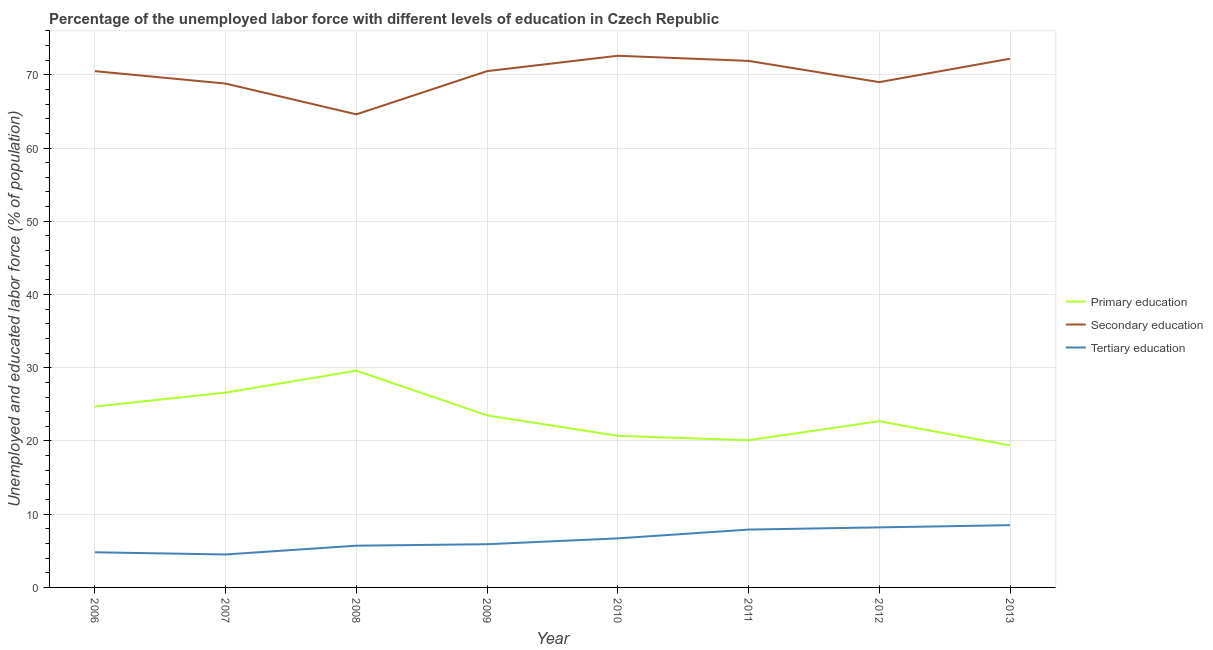How many different coloured lines are there?
Provide a short and direct response. 3. Does the line corresponding to percentage of labor force who received primary education intersect with the line corresponding to percentage of labor force who received tertiary education?
Keep it short and to the point. No. Is the number of lines equal to the number of legend labels?
Provide a short and direct response. Yes. What is the percentage of labor force who received tertiary education in 2011?
Your answer should be very brief. 7.9. Across all years, what is the maximum percentage of labor force who received primary education?
Provide a succinct answer. 29.6. Across all years, what is the minimum percentage of labor force who received secondary education?
Offer a terse response. 64.6. In which year was the percentage of labor force who received tertiary education minimum?
Keep it short and to the point. 2007. What is the total percentage of labor force who received tertiary education in the graph?
Your answer should be compact. 52.2. What is the difference between the percentage of labor force who received tertiary education in 2008 and that in 2011?
Provide a short and direct response. -2.2. What is the difference between the percentage of labor force who received secondary education in 2012 and the percentage of labor force who received tertiary education in 2008?
Provide a short and direct response. 63.3. What is the average percentage of labor force who received primary education per year?
Provide a succinct answer. 23.41. In the year 2009, what is the difference between the percentage of labor force who received secondary education and percentage of labor force who received primary education?
Ensure brevity in your answer.  47. What is the ratio of the percentage of labor force who received tertiary education in 2008 to that in 2010?
Provide a short and direct response. 0.85. Is the percentage of labor force who received tertiary education in 2006 less than that in 2008?
Give a very brief answer. Yes. What is the difference between the highest and the second highest percentage of labor force who received tertiary education?
Offer a very short reply. 0.3. What is the difference between the highest and the lowest percentage of labor force who received primary education?
Make the answer very short. 10.2. Does the percentage of labor force who received tertiary education monotonically increase over the years?
Provide a short and direct response. No. Is the percentage of labor force who received primary education strictly greater than the percentage of labor force who received tertiary education over the years?
Ensure brevity in your answer.  Yes. Is the percentage of labor force who received secondary education strictly less than the percentage of labor force who received primary education over the years?
Give a very brief answer. No. How many lines are there?
Ensure brevity in your answer.  3. How many years are there in the graph?
Your answer should be compact. 8. Are the values on the major ticks of Y-axis written in scientific E-notation?
Your response must be concise. No. Does the graph contain any zero values?
Make the answer very short. No. Where does the legend appear in the graph?
Offer a terse response. Center right. How are the legend labels stacked?
Your answer should be very brief. Vertical. What is the title of the graph?
Offer a very short reply. Percentage of the unemployed labor force with different levels of education in Czech Republic. Does "Labor Tax" appear as one of the legend labels in the graph?
Offer a terse response. No. What is the label or title of the X-axis?
Give a very brief answer. Year. What is the label or title of the Y-axis?
Offer a very short reply. Unemployed and educated labor force (% of population). What is the Unemployed and educated labor force (% of population) in Primary education in 2006?
Your response must be concise. 24.7. What is the Unemployed and educated labor force (% of population) in Secondary education in 2006?
Provide a succinct answer. 70.5. What is the Unemployed and educated labor force (% of population) of Tertiary education in 2006?
Your answer should be very brief. 4.8. What is the Unemployed and educated labor force (% of population) in Primary education in 2007?
Give a very brief answer. 26.6. What is the Unemployed and educated labor force (% of population) of Secondary education in 2007?
Keep it short and to the point. 68.8. What is the Unemployed and educated labor force (% of population) in Primary education in 2008?
Provide a succinct answer. 29.6. What is the Unemployed and educated labor force (% of population) of Secondary education in 2008?
Ensure brevity in your answer.  64.6. What is the Unemployed and educated labor force (% of population) in Tertiary education in 2008?
Make the answer very short. 5.7. What is the Unemployed and educated labor force (% of population) of Secondary education in 2009?
Ensure brevity in your answer.  70.5. What is the Unemployed and educated labor force (% of population) in Tertiary education in 2009?
Your answer should be compact. 5.9. What is the Unemployed and educated labor force (% of population) of Primary education in 2010?
Give a very brief answer. 20.7. What is the Unemployed and educated labor force (% of population) in Secondary education in 2010?
Give a very brief answer. 72.6. What is the Unemployed and educated labor force (% of population) of Tertiary education in 2010?
Give a very brief answer. 6.7. What is the Unemployed and educated labor force (% of population) in Primary education in 2011?
Keep it short and to the point. 20.1. What is the Unemployed and educated labor force (% of population) of Secondary education in 2011?
Offer a terse response. 71.9. What is the Unemployed and educated labor force (% of population) of Tertiary education in 2011?
Provide a succinct answer. 7.9. What is the Unemployed and educated labor force (% of population) of Primary education in 2012?
Provide a short and direct response. 22.7. What is the Unemployed and educated labor force (% of population) in Secondary education in 2012?
Offer a terse response. 69. What is the Unemployed and educated labor force (% of population) of Tertiary education in 2012?
Offer a very short reply. 8.2. What is the Unemployed and educated labor force (% of population) of Primary education in 2013?
Keep it short and to the point. 19.4. What is the Unemployed and educated labor force (% of population) of Secondary education in 2013?
Your answer should be compact. 72.2. What is the Unemployed and educated labor force (% of population) of Tertiary education in 2013?
Your response must be concise. 8.5. Across all years, what is the maximum Unemployed and educated labor force (% of population) in Primary education?
Ensure brevity in your answer.  29.6. Across all years, what is the maximum Unemployed and educated labor force (% of population) of Secondary education?
Give a very brief answer. 72.6. Across all years, what is the minimum Unemployed and educated labor force (% of population) in Primary education?
Offer a very short reply. 19.4. Across all years, what is the minimum Unemployed and educated labor force (% of population) of Secondary education?
Provide a short and direct response. 64.6. Across all years, what is the minimum Unemployed and educated labor force (% of population) of Tertiary education?
Offer a very short reply. 4.5. What is the total Unemployed and educated labor force (% of population) in Primary education in the graph?
Ensure brevity in your answer.  187.3. What is the total Unemployed and educated labor force (% of population) of Secondary education in the graph?
Ensure brevity in your answer.  560.1. What is the total Unemployed and educated labor force (% of population) in Tertiary education in the graph?
Provide a short and direct response. 52.2. What is the difference between the Unemployed and educated labor force (% of population) of Primary education in 2006 and that in 2007?
Provide a succinct answer. -1.9. What is the difference between the Unemployed and educated labor force (% of population) in Primary education in 2006 and that in 2008?
Your response must be concise. -4.9. What is the difference between the Unemployed and educated labor force (% of population) of Secondary education in 2006 and that in 2008?
Your answer should be very brief. 5.9. What is the difference between the Unemployed and educated labor force (% of population) in Tertiary education in 2006 and that in 2008?
Offer a very short reply. -0.9. What is the difference between the Unemployed and educated labor force (% of population) in Secondary education in 2006 and that in 2009?
Provide a short and direct response. 0. What is the difference between the Unemployed and educated labor force (% of population) in Tertiary education in 2006 and that in 2009?
Your response must be concise. -1.1. What is the difference between the Unemployed and educated labor force (% of population) in Primary education in 2006 and that in 2010?
Your response must be concise. 4. What is the difference between the Unemployed and educated labor force (% of population) in Secondary education in 2006 and that in 2010?
Your answer should be compact. -2.1. What is the difference between the Unemployed and educated labor force (% of population) in Tertiary education in 2006 and that in 2010?
Offer a terse response. -1.9. What is the difference between the Unemployed and educated labor force (% of population) of Secondary education in 2006 and that in 2012?
Give a very brief answer. 1.5. What is the difference between the Unemployed and educated labor force (% of population) of Tertiary education in 2006 and that in 2012?
Your answer should be compact. -3.4. What is the difference between the Unemployed and educated labor force (% of population) in Primary education in 2006 and that in 2013?
Give a very brief answer. 5.3. What is the difference between the Unemployed and educated labor force (% of population) of Secondary education in 2006 and that in 2013?
Keep it short and to the point. -1.7. What is the difference between the Unemployed and educated labor force (% of population) of Primary education in 2007 and that in 2008?
Your response must be concise. -3. What is the difference between the Unemployed and educated labor force (% of population) in Secondary education in 2007 and that in 2008?
Offer a terse response. 4.2. What is the difference between the Unemployed and educated labor force (% of population) of Primary education in 2007 and that in 2009?
Provide a succinct answer. 3.1. What is the difference between the Unemployed and educated labor force (% of population) in Secondary education in 2007 and that in 2009?
Provide a succinct answer. -1.7. What is the difference between the Unemployed and educated labor force (% of population) of Tertiary education in 2007 and that in 2009?
Give a very brief answer. -1.4. What is the difference between the Unemployed and educated labor force (% of population) in Tertiary education in 2007 and that in 2010?
Offer a very short reply. -2.2. What is the difference between the Unemployed and educated labor force (% of population) of Secondary education in 2007 and that in 2011?
Ensure brevity in your answer.  -3.1. What is the difference between the Unemployed and educated labor force (% of population) of Primary education in 2007 and that in 2013?
Give a very brief answer. 7.2. What is the difference between the Unemployed and educated labor force (% of population) of Secondary education in 2007 and that in 2013?
Make the answer very short. -3.4. What is the difference between the Unemployed and educated labor force (% of population) in Tertiary education in 2007 and that in 2013?
Give a very brief answer. -4. What is the difference between the Unemployed and educated labor force (% of population) of Tertiary education in 2008 and that in 2009?
Ensure brevity in your answer.  -0.2. What is the difference between the Unemployed and educated labor force (% of population) of Primary education in 2008 and that in 2010?
Keep it short and to the point. 8.9. What is the difference between the Unemployed and educated labor force (% of population) of Primary education in 2008 and that in 2012?
Your answer should be compact. 6.9. What is the difference between the Unemployed and educated labor force (% of population) in Secondary education in 2008 and that in 2012?
Provide a short and direct response. -4.4. What is the difference between the Unemployed and educated labor force (% of population) in Tertiary education in 2008 and that in 2012?
Provide a short and direct response. -2.5. What is the difference between the Unemployed and educated labor force (% of population) of Secondary education in 2008 and that in 2013?
Make the answer very short. -7.6. What is the difference between the Unemployed and educated labor force (% of population) in Primary education in 2009 and that in 2010?
Your answer should be compact. 2.8. What is the difference between the Unemployed and educated labor force (% of population) in Primary education in 2009 and that in 2011?
Keep it short and to the point. 3.4. What is the difference between the Unemployed and educated labor force (% of population) in Secondary education in 2009 and that in 2011?
Offer a very short reply. -1.4. What is the difference between the Unemployed and educated labor force (% of population) of Tertiary education in 2009 and that in 2011?
Provide a succinct answer. -2. What is the difference between the Unemployed and educated labor force (% of population) of Primary education in 2009 and that in 2012?
Your answer should be compact. 0.8. What is the difference between the Unemployed and educated labor force (% of population) of Secondary education in 2009 and that in 2012?
Your answer should be compact. 1.5. What is the difference between the Unemployed and educated labor force (% of population) of Primary education in 2010 and that in 2011?
Your response must be concise. 0.6. What is the difference between the Unemployed and educated labor force (% of population) of Secondary education in 2010 and that in 2011?
Your answer should be compact. 0.7. What is the difference between the Unemployed and educated labor force (% of population) in Primary education in 2010 and that in 2012?
Keep it short and to the point. -2. What is the difference between the Unemployed and educated labor force (% of population) of Secondary education in 2010 and that in 2012?
Keep it short and to the point. 3.6. What is the difference between the Unemployed and educated labor force (% of population) of Tertiary education in 2010 and that in 2012?
Ensure brevity in your answer.  -1.5. What is the difference between the Unemployed and educated labor force (% of population) in Primary education in 2010 and that in 2013?
Keep it short and to the point. 1.3. What is the difference between the Unemployed and educated labor force (% of population) in Secondary education in 2011 and that in 2012?
Ensure brevity in your answer.  2.9. What is the difference between the Unemployed and educated labor force (% of population) in Primary education in 2011 and that in 2013?
Ensure brevity in your answer.  0.7. What is the difference between the Unemployed and educated labor force (% of population) in Tertiary education in 2011 and that in 2013?
Your answer should be compact. -0.6. What is the difference between the Unemployed and educated labor force (% of population) of Primary education in 2012 and that in 2013?
Give a very brief answer. 3.3. What is the difference between the Unemployed and educated labor force (% of population) in Secondary education in 2012 and that in 2013?
Keep it short and to the point. -3.2. What is the difference between the Unemployed and educated labor force (% of population) in Tertiary education in 2012 and that in 2013?
Offer a very short reply. -0.3. What is the difference between the Unemployed and educated labor force (% of population) in Primary education in 2006 and the Unemployed and educated labor force (% of population) in Secondary education in 2007?
Ensure brevity in your answer.  -44.1. What is the difference between the Unemployed and educated labor force (% of population) in Primary education in 2006 and the Unemployed and educated labor force (% of population) in Tertiary education in 2007?
Your answer should be compact. 20.2. What is the difference between the Unemployed and educated labor force (% of population) of Primary education in 2006 and the Unemployed and educated labor force (% of population) of Secondary education in 2008?
Your answer should be very brief. -39.9. What is the difference between the Unemployed and educated labor force (% of population) in Primary education in 2006 and the Unemployed and educated labor force (% of population) in Tertiary education in 2008?
Offer a very short reply. 19. What is the difference between the Unemployed and educated labor force (% of population) of Secondary education in 2006 and the Unemployed and educated labor force (% of population) of Tertiary education in 2008?
Your answer should be very brief. 64.8. What is the difference between the Unemployed and educated labor force (% of population) in Primary education in 2006 and the Unemployed and educated labor force (% of population) in Secondary education in 2009?
Make the answer very short. -45.8. What is the difference between the Unemployed and educated labor force (% of population) in Secondary education in 2006 and the Unemployed and educated labor force (% of population) in Tertiary education in 2009?
Your answer should be very brief. 64.6. What is the difference between the Unemployed and educated labor force (% of population) in Primary education in 2006 and the Unemployed and educated labor force (% of population) in Secondary education in 2010?
Ensure brevity in your answer.  -47.9. What is the difference between the Unemployed and educated labor force (% of population) of Primary education in 2006 and the Unemployed and educated labor force (% of population) of Tertiary education in 2010?
Give a very brief answer. 18. What is the difference between the Unemployed and educated labor force (% of population) in Secondary education in 2006 and the Unemployed and educated labor force (% of population) in Tertiary education in 2010?
Offer a very short reply. 63.8. What is the difference between the Unemployed and educated labor force (% of population) in Primary education in 2006 and the Unemployed and educated labor force (% of population) in Secondary education in 2011?
Your response must be concise. -47.2. What is the difference between the Unemployed and educated labor force (% of population) of Primary education in 2006 and the Unemployed and educated labor force (% of population) of Tertiary education in 2011?
Ensure brevity in your answer.  16.8. What is the difference between the Unemployed and educated labor force (% of population) in Secondary education in 2006 and the Unemployed and educated labor force (% of population) in Tertiary education in 2011?
Give a very brief answer. 62.6. What is the difference between the Unemployed and educated labor force (% of population) of Primary education in 2006 and the Unemployed and educated labor force (% of population) of Secondary education in 2012?
Offer a very short reply. -44.3. What is the difference between the Unemployed and educated labor force (% of population) of Primary education in 2006 and the Unemployed and educated labor force (% of population) of Tertiary education in 2012?
Provide a succinct answer. 16.5. What is the difference between the Unemployed and educated labor force (% of population) of Secondary education in 2006 and the Unemployed and educated labor force (% of population) of Tertiary education in 2012?
Offer a terse response. 62.3. What is the difference between the Unemployed and educated labor force (% of population) in Primary education in 2006 and the Unemployed and educated labor force (% of population) in Secondary education in 2013?
Make the answer very short. -47.5. What is the difference between the Unemployed and educated labor force (% of population) in Primary education in 2006 and the Unemployed and educated labor force (% of population) in Tertiary education in 2013?
Offer a very short reply. 16.2. What is the difference between the Unemployed and educated labor force (% of population) in Primary education in 2007 and the Unemployed and educated labor force (% of population) in Secondary education in 2008?
Your response must be concise. -38. What is the difference between the Unemployed and educated labor force (% of population) in Primary education in 2007 and the Unemployed and educated labor force (% of population) in Tertiary education in 2008?
Provide a short and direct response. 20.9. What is the difference between the Unemployed and educated labor force (% of population) of Secondary education in 2007 and the Unemployed and educated labor force (% of population) of Tertiary education in 2008?
Offer a terse response. 63.1. What is the difference between the Unemployed and educated labor force (% of population) in Primary education in 2007 and the Unemployed and educated labor force (% of population) in Secondary education in 2009?
Offer a terse response. -43.9. What is the difference between the Unemployed and educated labor force (% of population) of Primary education in 2007 and the Unemployed and educated labor force (% of population) of Tertiary education in 2009?
Your response must be concise. 20.7. What is the difference between the Unemployed and educated labor force (% of population) of Secondary education in 2007 and the Unemployed and educated labor force (% of population) of Tertiary education in 2009?
Offer a terse response. 62.9. What is the difference between the Unemployed and educated labor force (% of population) of Primary education in 2007 and the Unemployed and educated labor force (% of population) of Secondary education in 2010?
Offer a very short reply. -46. What is the difference between the Unemployed and educated labor force (% of population) of Primary education in 2007 and the Unemployed and educated labor force (% of population) of Tertiary education in 2010?
Provide a succinct answer. 19.9. What is the difference between the Unemployed and educated labor force (% of population) in Secondary education in 2007 and the Unemployed and educated labor force (% of population) in Tertiary education in 2010?
Make the answer very short. 62.1. What is the difference between the Unemployed and educated labor force (% of population) of Primary education in 2007 and the Unemployed and educated labor force (% of population) of Secondary education in 2011?
Provide a succinct answer. -45.3. What is the difference between the Unemployed and educated labor force (% of population) of Primary education in 2007 and the Unemployed and educated labor force (% of population) of Tertiary education in 2011?
Your answer should be very brief. 18.7. What is the difference between the Unemployed and educated labor force (% of population) of Secondary education in 2007 and the Unemployed and educated labor force (% of population) of Tertiary education in 2011?
Offer a terse response. 60.9. What is the difference between the Unemployed and educated labor force (% of population) in Primary education in 2007 and the Unemployed and educated labor force (% of population) in Secondary education in 2012?
Offer a terse response. -42.4. What is the difference between the Unemployed and educated labor force (% of population) of Primary education in 2007 and the Unemployed and educated labor force (% of population) of Tertiary education in 2012?
Offer a terse response. 18.4. What is the difference between the Unemployed and educated labor force (% of population) of Secondary education in 2007 and the Unemployed and educated labor force (% of population) of Tertiary education in 2012?
Your answer should be compact. 60.6. What is the difference between the Unemployed and educated labor force (% of population) in Primary education in 2007 and the Unemployed and educated labor force (% of population) in Secondary education in 2013?
Ensure brevity in your answer.  -45.6. What is the difference between the Unemployed and educated labor force (% of population) of Secondary education in 2007 and the Unemployed and educated labor force (% of population) of Tertiary education in 2013?
Offer a terse response. 60.3. What is the difference between the Unemployed and educated labor force (% of population) of Primary education in 2008 and the Unemployed and educated labor force (% of population) of Secondary education in 2009?
Provide a succinct answer. -40.9. What is the difference between the Unemployed and educated labor force (% of population) of Primary education in 2008 and the Unemployed and educated labor force (% of population) of Tertiary education in 2009?
Offer a very short reply. 23.7. What is the difference between the Unemployed and educated labor force (% of population) of Secondary education in 2008 and the Unemployed and educated labor force (% of population) of Tertiary education in 2009?
Your answer should be very brief. 58.7. What is the difference between the Unemployed and educated labor force (% of population) of Primary education in 2008 and the Unemployed and educated labor force (% of population) of Secondary education in 2010?
Offer a very short reply. -43. What is the difference between the Unemployed and educated labor force (% of population) in Primary education in 2008 and the Unemployed and educated labor force (% of population) in Tertiary education in 2010?
Offer a terse response. 22.9. What is the difference between the Unemployed and educated labor force (% of population) in Secondary education in 2008 and the Unemployed and educated labor force (% of population) in Tertiary education in 2010?
Give a very brief answer. 57.9. What is the difference between the Unemployed and educated labor force (% of population) in Primary education in 2008 and the Unemployed and educated labor force (% of population) in Secondary education in 2011?
Your answer should be very brief. -42.3. What is the difference between the Unemployed and educated labor force (% of population) of Primary education in 2008 and the Unemployed and educated labor force (% of population) of Tertiary education in 2011?
Keep it short and to the point. 21.7. What is the difference between the Unemployed and educated labor force (% of population) in Secondary education in 2008 and the Unemployed and educated labor force (% of population) in Tertiary education in 2011?
Keep it short and to the point. 56.7. What is the difference between the Unemployed and educated labor force (% of population) in Primary education in 2008 and the Unemployed and educated labor force (% of population) in Secondary education in 2012?
Keep it short and to the point. -39.4. What is the difference between the Unemployed and educated labor force (% of population) in Primary education in 2008 and the Unemployed and educated labor force (% of population) in Tertiary education in 2012?
Your answer should be very brief. 21.4. What is the difference between the Unemployed and educated labor force (% of population) of Secondary education in 2008 and the Unemployed and educated labor force (% of population) of Tertiary education in 2012?
Give a very brief answer. 56.4. What is the difference between the Unemployed and educated labor force (% of population) of Primary education in 2008 and the Unemployed and educated labor force (% of population) of Secondary education in 2013?
Make the answer very short. -42.6. What is the difference between the Unemployed and educated labor force (% of population) of Primary education in 2008 and the Unemployed and educated labor force (% of population) of Tertiary education in 2013?
Keep it short and to the point. 21.1. What is the difference between the Unemployed and educated labor force (% of population) in Secondary education in 2008 and the Unemployed and educated labor force (% of population) in Tertiary education in 2013?
Your answer should be compact. 56.1. What is the difference between the Unemployed and educated labor force (% of population) in Primary education in 2009 and the Unemployed and educated labor force (% of population) in Secondary education in 2010?
Your response must be concise. -49.1. What is the difference between the Unemployed and educated labor force (% of population) in Primary education in 2009 and the Unemployed and educated labor force (% of population) in Tertiary education in 2010?
Your response must be concise. 16.8. What is the difference between the Unemployed and educated labor force (% of population) of Secondary education in 2009 and the Unemployed and educated labor force (% of population) of Tertiary education in 2010?
Ensure brevity in your answer.  63.8. What is the difference between the Unemployed and educated labor force (% of population) of Primary education in 2009 and the Unemployed and educated labor force (% of population) of Secondary education in 2011?
Give a very brief answer. -48.4. What is the difference between the Unemployed and educated labor force (% of population) of Primary education in 2009 and the Unemployed and educated labor force (% of population) of Tertiary education in 2011?
Ensure brevity in your answer.  15.6. What is the difference between the Unemployed and educated labor force (% of population) of Secondary education in 2009 and the Unemployed and educated labor force (% of population) of Tertiary education in 2011?
Provide a short and direct response. 62.6. What is the difference between the Unemployed and educated labor force (% of population) of Primary education in 2009 and the Unemployed and educated labor force (% of population) of Secondary education in 2012?
Offer a very short reply. -45.5. What is the difference between the Unemployed and educated labor force (% of population) of Primary education in 2009 and the Unemployed and educated labor force (% of population) of Tertiary education in 2012?
Make the answer very short. 15.3. What is the difference between the Unemployed and educated labor force (% of population) in Secondary education in 2009 and the Unemployed and educated labor force (% of population) in Tertiary education in 2012?
Your answer should be very brief. 62.3. What is the difference between the Unemployed and educated labor force (% of population) in Primary education in 2009 and the Unemployed and educated labor force (% of population) in Secondary education in 2013?
Your response must be concise. -48.7. What is the difference between the Unemployed and educated labor force (% of population) of Primary education in 2009 and the Unemployed and educated labor force (% of population) of Tertiary education in 2013?
Offer a very short reply. 15. What is the difference between the Unemployed and educated labor force (% of population) in Secondary education in 2009 and the Unemployed and educated labor force (% of population) in Tertiary education in 2013?
Your answer should be compact. 62. What is the difference between the Unemployed and educated labor force (% of population) of Primary education in 2010 and the Unemployed and educated labor force (% of population) of Secondary education in 2011?
Keep it short and to the point. -51.2. What is the difference between the Unemployed and educated labor force (% of population) of Secondary education in 2010 and the Unemployed and educated labor force (% of population) of Tertiary education in 2011?
Keep it short and to the point. 64.7. What is the difference between the Unemployed and educated labor force (% of population) in Primary education in 2010 and the Unemployed and educated labor force (% of population) in Secondary education in 2012?
Provide a short and direct response. -48.3. What is the difference between the Unemployed and educated labor force (% of population) of Secondary education in 2010 and the Unemployed and educated labor force (% of population) of Tertiary education in 2012?
Offer a very short reply. 64.4. What is the difference between the Unemployed and educated labor force (% of population) of Primary education in 2010 and the Unemployed and educated labor force (% of population) of Secondary education in 2013?
Offer a very short reply. -51.5. What is the difference between the Unemployed and educated labor force (% of population) of Primary education in 2010 and the Unemployed and educated labor force (% of population) of Tertiary education in 2013?
Give a very brief answer. 12.2. What is the difference between the Unemployed and educated labor force (% of population) of Secondary education in 2010 and the Unemployed and educated labor force (% of population) of Tertiary education in 2013?
Provide a succinct answer. 64.1. What is the difference between the Unemployed and educated labor force (% of population) of Primary education in 2011 and the Unemployed and educated labor force (% of population) of Secondary education in 2012?
Your answer should be very brief. -48.9. What is the difference between the Unemployed and educated labor force (% of population) in Secondary education in 2011 and the Unemployed and educated labor force (% of population) in Tertiary education in 2012?
Give a very brief answer. 63.7. What is the difference between the Unemployed and educated labor force (% of population) of Primary education in 2011 and the Unemployed and educated labor force (% of population) of Secondary education in 2013?
Ensure brevity in your answer.  -52.1. What is the difference between the Unemployed and educated labor force (% of population) of Primary education in 2011 and the Unemployed and educated labor force (% of population) of Tertiary education in 2013?
Give a very brief answer. 11.6. What is the difference between the Unemployed and educated labor force (% of population) of Secondary education in 2011 and the Unemployed and educated labor force (% of population) of Tertiary education in 2013?
Provide a short and direct response. 63.4. What is the difference between the Unemployed and educated labor force (% of population) in Primary education in 2012 and the Unemployed and educated labor force (% of population) in Secondary education in 2013?
Your response must be concise. -49.5. What is the difference between the Unemployed and educated labor force (% of population) of Secondary education in 2012 and the Unemployed and educated labor force (% of population) of Tertiary education in 2013?
Your answer should be compact. 60.5. What is the average Unemployed and educated labor force (% of population) in Primary education per year?
Provide a succinct answer. 23.41. What is the average Unemployed and educated labor force (% of population) of Secondary education per year?
Ensure brevity in your answer.  70.01. What is the average Unemployed and educated labor force (% of population) in Tertiary education per year?
Ensure brevity in your answer.  6.53. In the year 2006, what is the difference between the Unemployed and educated labor force (% of population) in Primary education and Unemployed and educated labor force (% of population) in Secondary education?
Your answer should be compact. -45.8. In the year 2006, what is the difference between the Unemployed and educated labor force (% of population) of Primary education and Unemployed and educated labor force (% of population) of Tertiary education?
Provide a short and direct response. 19.9. In the year 2006, what is the difference between the Unemployed and educated labor force (% of population) in Secondary education and Unemployed and educated labor force (% of population) in Tertiary education?
Offer a very short reply. 65.7. In the year 2007, what is the difference between the Unemployed and educated labor force (% of population) in Primary education and Unemployed and educated labor force (% of population) in Secondary education?
Offer a very short reply. -42.2. In the year 2007, what is the difference between the Unemployed and educated labor force (% of population) of Primary education and Unemployed and educated labor force (% of population) of Tertiary education?
Make the answer very short. 22.1. In the year 2007, what is the difference between the Unemployed and educated labor force (% of population) in Secondary education and Unemployed and educated labor force (% of population) in Tertiary education?
Make the answer very short. 64.3. In the year 2008, what is the difference between the Unemployed and educated labor force (% of population) of Primary education and Unemployed and educated labor force (% of population) of Secondary education?
Your response must be concise. -35. In the year 2008, what is the difference between the Unemployed and educated labor force (% of population) in Primary education and Unemployed and educated labor force (% of population) in Tertiary education?
Provide a short and direct response. 23.9. In the year 2008, what is the difference between the Unemployed and educated labor force (% of population) of Secondary education and Unemployed and educated labor force (% of population) of Tertiary education?
Your answer should be compact. 58.9. In the year 2009, what is the difference between the Unemployed and educated labor force (% of population) in Primary education and Unemployed and educated labor force (% of population) in Secondary education?
Give a very brief answer. -47. In the year 2009, what is the difference between the Unemployed and educated labor force (% of population) of Secondary education and Unemployed and educated labor force (% of population) of Tertiary education?
Keep it short and to the point. 64.6. In the year 2010, what is the difference between the Unemployed and educated labor force (% of population) in Primary education and Unemployed and educated labor force (% of population) in Secondary education?
Make the answer very short. -51.9. In the year 2010, what is the difference between the Unemployed and educated labor force (% of population) in Primary education and Unemployed and educated labor force (% of population) in Tertiary education?
Your response must be concise. 14. In the year 2010, what is the difference between the Unemployed and educated labor force (% of population) of Secondary education and Unemployed and educated labor force (% of population) of Tertiary education?
Offer a very short reply. 65.9. In the year 2011, what is the difference between the Unemployed and educated labor force (% of population) in Primary education and Unemployed and educated labor force (% of population) in Secondary education?
Offer a terse response. -51.8. In the year 2011, what is the difference between the Unemployed and educated labor force (% of population) in Primary education and Unemployed and educated labor force (% of population) in Tertiary education?
Give a very brief answer. 12.2. In the year 2011, what is the difference between the Unemployed and educated labor force (% of population) of Secondary education and Unemployed and educated labor force (% of population) of Tertiary education?
Your answer should be very brief. 64. In the year 2012, what is the difference between the Unemployed and educated labor force (% of population) in Primary education and Unemployed and educated labor force (% of population) in Secondary education?
Your answer should be very brief. -46.3. In the year 2012, what is the difference between the Unemployed and educated labor force (% of population) in Primary education and Unemployed and educated labor force (% of population) in Tertiary education?
Your response must be concise. 14.5. In the year 2012, what is the difference between the Unemployed and educated labor force (% of population) in Secondary education and Unemployed and educated labor force (% of population) in Tertiary education?
Make the answer very short. 60.8. In the year 2013, what is the difference between the Unemployed and educated labor force (% of population) in Primary education and Unemployed and educated labor force (% of population) in Secondary education?
Provide a succinct answer. -52.8. In the year 2013, what is the difference between the Unemployed and educated labor force (% of population) in Secondary education and Unemployed and educated labor force (% of population) in Tertiary education?
Give a very brief answer. 63.7. What is the ratio of the Unemployed and educated labor force (% of population) of Primary education in 2006 to that in 2007?
Keep it short and to the point. 0.93. What is the ratio of the Unemployed and educated labor force (% of population) in Secondary education in 2006 to that in 2007?
Offer a very short reply. 1.02. What is the ratio of the Unemployed and educated labor force (% of population) in Tertiary education in 2006 to that in 2007?
Offer a terse response. 1.07. What is the ratio of the Unemployed and educated labor force (% of population) in Primary education in 2006 to that in 2008?
Provide a short and direct response. 0.83. What is the ratio of the Unemployed and educated labor force (% of population) in Secondary education in 2006 to that in 2008?
Give a very brief answer. 1.09. What is the ratio of the Unemployed and educated labor force (% of population) of Tertiary education in 2006 to that in 2008?
Your answer should be very brief. 0.84. What is the ratio of the Unemployed and educated labor force (% of population) in Primary education in 2006 to that in 2009?
Offer a terse response. 1.05. What is the ratio of the Unemployed and educated labor force (% of population) of Secondary education in 2006 to that in 2009?
Offer a terse response. 1. What is the ratio of the Unemployed and educated labor force (% of population) of Tertiary education in 2006 to that in 2009?
Give a very brief answer. 0.81. What is the ratio of the Unemployed and educated labor force (% of population) in Primary education in 2006 to that in 2010?
Ensure brevity in your answer.  1.19. What is the ratio of the Unemployed and educated labor force (% of population) of Secondary education in 2006 to that in 2010?
Your answer should be very brief. 0.97. What is the ratio of the Unemployed and educated labor force (% of population) in Tertiary education in 2006 to that in 2010?
Your answer should be very brief. 0.72. What is the ratio of the Unemployed and educated labor force (% of population) in Primary education in 2006 to that in 2011?
Your answer should be very brief. 1.23. What is the ratio of the Unemployed and educated labor force (% of population) in Secondary education in 2006 to that in 2011?
Offer a terse response. 0.98. What is the ratio of the Unemployed and educated labor force (% of population) in Tertiary education in 2006 to that in 2011?
Make the answer very short. 0.61. What is the ratio of the Unemployed and educated labor force (% of population) of Primary education in 2006 to that in 2012?
Ensure brevity in your answer.  1.09. What is the ratio of the Unemployed and educated labor force (% of population) of Secondary education in 2006 to that in 2012?
Your answer should be very brief. 1.02. What is the ratio of the Unemployed and educated labor force (% of population) of Tertiary education in 2006 to that in 2012?
Offer a terse response. 0.59. What is the ratio of the Unemployed and educated labor force (% of population) in Primary education in 2006 to that in 2013?
Offer a very short reply. 1.27. What is the ratio of the Unemployed and educated labor force (% of population) in Secondary education in 2006 to that in 2013?
Ensure brevity in your answer.  0.98. What is the ratio of the Unemployed and educated labor force (% of population) of Tertiary education in 2006 to that in 2013?
Your response must be concise. 0.56. What is the ratio of the Unemployed and educated labor force (% of population) in Primary education in 2007 to that in 2008?
Provide a short and direct response. 0.9. What is the ratio of the Unemployed and educated labor force (% of population) in Secondary education in 2007 to that in 2008?
Your answer should be very brief. 1.06. What is the ratio of the Unemployed and educated labor force (% of population) of Tertiary education in 2007 to that in 2008?
Your answer should be compact. 0.79. What is the ratio of the Unemployed and educated labor force (% of population) in Primary education in 2007 to that in 2009?
Ensure brevity in your answer.  1.13. What is the ratio of the Unemployed and educated labor force (% of population) in Secondary education in 2007 to that in 2009?
Make the answer very short. 0.98. What is the ratio of the Unemployed and educated labor force (% of population) of Tertiary education in 2007 to that in 2009?
Offer a very short reply. 0.76. What is the ratio of the Unemployed and educated labor force (% of population) in Primary education in 2007 to that in 2010?
Your response must be concise. 1.28. What is the ratio of the Unemployed and educated labor force (% of population) in Secondary education in 2007 to that in 2010?
Your answer should be very brief. 0.95. What is the ratio of the Unemployed and educated labor force (% of population) of Tertiary education in 2007 to that in 2010?
Make the answer very short. 0.67. What is the ratio of the Unemployed and educated labor force (% of population) in Primary education in 2007 to that in 2011?
Provide a short and direct response. 1.32. What is the ratio of the Unemployed and educated labor force (% of population) of Secondary education in 2007 to that in 2011?
Provide a succinct answer. 0.96. What is the ratio of the Unemployed and educated labor force (% of population) in Tertiary education in 2007 to that in 2011?
Offer a terse response. 0.57. What is the ratio of the Unemployed and educated labor force (% of population) of Primary education in 2007 to that in 2012?
Provide a succinct answer. 1.17. What is the ratio of the Unemployed and educated labor force (% of population) in Secondary education in 2007 to that in 2012?
Your answer should be compact. 1. What is the ratio of the Unemployed and educated labor force (% of population) in Tertiary education in 2007 to that in 2012?
Keep it short and to the point. 0.55. What is the ratio of the Unemployed and educated labor force (% of population) in Primary education in 2007 to that in 2013?
Give a very brief answer. 1.37. What is the ratio of the Unemployed and educated labor force (% of population) of Secondary education in 2007 to that in 2013?
Your answer should be very brief. 0.95. What is the ratio of the Unemployed and educated labor force (% of population) of Tertiary education in 2007 to that in 2013?
Your answer should be very brief. 0.53. What is the ratio of the Unemployed and educated labor force (% of population) in Primary education in 2008 to that in 2009?
Provide a short and direct response. 1.26. What is the ratio of the Unemployed and educated labor force (% of population) in Secondary education in 2008 to that in 2009?
Offer a terse response. 0.92. What is the ratio of the Unemployed and educated labor force (% of population) in Tertiary education in 2008 to that in 2009?
Your answer should be compact. 0.97. What is the ratio of the Unemployed and educated labor force (% of population) of Primary education in 2008 to that in 2010?
Ensure brevity in your answer.  1.43. What is the ratio of the Unemployed and educated labor force (% of population) of Secondary education in 2008 to that in 2010?
Your response must be concise. 0.89. What is the ratio of the Unemployed and educated labor force (% of population) of Tertiary education in 2008 to that in 2010?
Provide a short and direct response. 0.85. What is the ratio of the Unemployed and educated labor force (% of population) in Primary education in 2008 to that in 2011?
Provide a short and direct response. 1.47. What is the ratio of the Unemployed and educated labor force (% of population) in Secondary education in 2008 to that in 2011?
Give a very brief answer. 0.9. What is the ratio of the Unemployed and educated labor force (% of population) of Tertiary education in 2008 to that in 2011?
Provide a short and direct response. 0.72. What is the ratio of the Unemployed and educated labor force (% of population) in Primary education in 2008 to that in 2012?
Keep it short and to the point. 1.3. What is the ratio of the Unemployed and educated labor force (% of population) of Secondary education in 2008 to that in 2012?
Provide a short and direct response. 0.94. What is the ratio of the Unemployed and educated labor force (% of population) in Tertiary education in 2008 to that in 2012?
Offer a very short reply. 0.7. What is the ratio of the Unemployed and educated labor force (% of population) in Primary education in 2008 to that in 2013?
Offer a very short reply. 1.53. What is the ratio of the Unemployed and educated labor force (% of population) in Secondary education in 2008 to that in 2013?
Make the answer very short. 0.89. What is the ratio of the Unemployed and educated labor force (% of population) in Tertiary education in 2008 to that in 2013?
Your response must be concise. 0.67. What is the ratio of the Unemployed and educated labor force (% of population) in Primary education in 2009 to that in 2010?
Ensure brevity in your answer.  1.14. What is the ratio of the Unemployed and educated labor force (% of population) in Secondary education in 2009 to that in 2010?
Make the answer very short. 0.97. What is the ratio of the Unemployed and educated labor force (% of population) of Tertiary education in 2009 to that in 2010?
Offer a terse response. 0.88. What is the ratio of the Unemployed and educated labor force (% of population) of Primary education in 2009 to that in 2011?
Your answer should be compact. 1.17. What is the ratio of the Unemployed and educated labor force (% of population) of Secondary education in 2009 to that in 2011?
Provide a short and direct response. 0.98. What is the ratio of the Unemployed and educated labor force (% of population) in Tertiary education in 2009 to that in 2011?
Ensure brevity in your answer.  0.75. What is the ratio of the Unemployed and educated labor force (% of population) in Primary education in 2009 to that in 2012?
Your response must be concise. 1.04. What is the ratio of the Unemployed and educated labor force (% of population) of Secondary education in 2009 to that in 2012?
Give a very brief answer. 1.02. What is the ratio of the Unemployed and educated labor force (% of population) of Tertiary education in 2009 to that in 2012?
Your response must be concise. 0.72. What is the ratio of the Unemployed and educated labor force (% of population) of Primary education in 2009 to that in 2013?
Offer a terse response. 1.21. What is the ratio of the Unemployed and educated labor force (% of population) of Secondary education in 2009 to that in 2013?
Keep it short and to the point. 0.98. What is the ratio of the Unemployed and educated labor force (% of population) of Tertiary education in 2009 to that in 2013?
Your answer should be compact. 0.69. What is the ratio of the Unemployed and educated labor force (% of population) in Primary education in 2010 to that in 2011?
Offer a very short reply. 1.03. What is the ratio of the Unemployed and educated labor force (% of population) in Secondary education in 2010 to that in 2011?
Offer a very short reply. 1.01. What is the ratio of the Unemployed and educated labor force (% of population) in Tertiary education in 2010 to that in 2011?
Offer a terse response. 0.85. What is the ratio of the Unemployed and educated labor force (% of population) in Primary education in 2010 to that in 2012?
Offer a very short reply. 0.91. What is the ratio of the Unemployed and educated labor force (% of population) of Secondary education in 2010 to that in 2012?
Your answer should be compact. 1.05. What is the ratio of the Unemployed and educated labor force (% of population) in Tertiary education in 2010 to that in 2012?
Provide a short and direct response. 0.82. What is the ratio of the Unemployed and educated labor force (% of population) of Primary education in 2010 to that in 2013?
Offer a terse response. 1.07. What is the ratio of the Unemployed and educated labor force (% of population) of Secondary education in 2010 to that in 2013?
Keep it short and to the point. 1.01. What is the ratio of the Unemployed and educated labor force (% of population) in Tertiary education in 2010 to that in 2013?
Make the answer very short. 0.79. What is the ratio of the Unemployed and educated labor force (% of population) of Primary education in 2011 to that in 2012?
Your response must be concise. 0.89. What is the ratio of the Unemployed and educated labor force (% of population) of Secondary education in 2011 to that in 2012?
Offer a terse response. 1.04. What is the ratio of the Unemployed and educated labor force (% of population) in Tertiary education in 2011 to that in 2012?
Your answer should be very brief. 0.96. What is the ratio of the Unemployed and educated labor force (% of population) in Primary education in 2011 to that in 2013?
Offer a very short reply. 1.04. What is the ratio of the Unemployed and educated labor force (% of population) of Secondary education in 2011 to that in 2013?
Offer a very short reply. 1. What is the ratio of the Unemployed and educated labor force (% of population) of Tertiary education in 2011 to that in 2013?
Offer a very short reply. 0.93. What is the ratio of the Unemployed and educated labor force (% of population) in Primary education in 2012 to that in 2013?
Provide a succinct answer. 1.17. What is the ratio of the Unemployed and educated labor force (% of population) in Secondary education in 2012 to that in 2013?
Give a very brief answer. 0.96. What is the ratio of the Unemployed and educated labor force (% of population) of Tertiary education in 2012 to that in 2013?
Keep it short and to the point. 0.96. What is the difference between the highest and the second highest Unemployed and educated labor force (% of population) of Primary education?
Your response must be concise. 3. What is the difference between the highest and the second highest Unemployed and educated labor force (% of population) of Secondary education?
Offer a very short reply. 0.4. What is the difference between the highest and the second highest Unemployed and educated labor force (% of population) of Tertiary education?
Offer a terse response. 0.3. What is the difference between the highest and the lowest Unemployed and educated labor force (% of population) in Primary education?
Keep it short and to the point. 10.2. What is the difference between the highest and the lowest Unemployed and educated labor force (% of population) in Tertiary education?
Give a very brief answer. 4. 